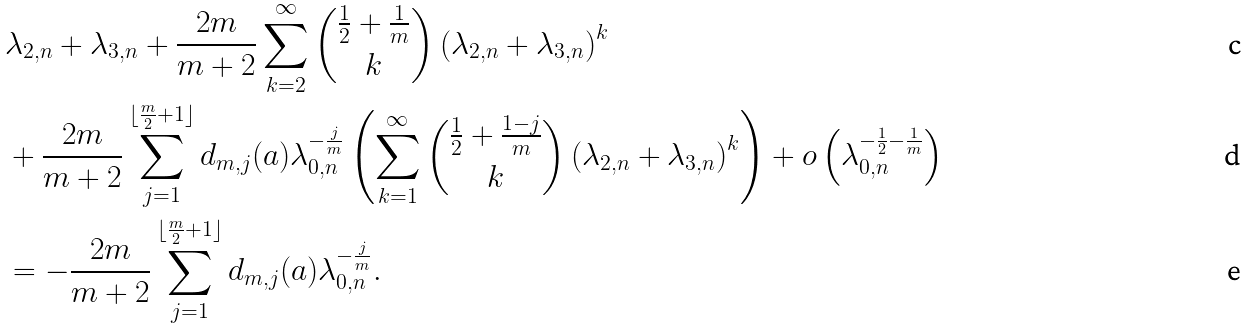Convert formula to latex. <formula><loc_0><loc_0><loc_500><loc_500>& \lambda _ { 2 , n } + \lambda _ { 3 , n } + \frac { 2 m } { m + 2 } \sum _ { k = 2 } ^ { \infty } { \frac { 1 } { 2 } + \frac { 1 } { m } \choose k } \left ( \lambda _ { 2 , n } + \lambda _ { 3 , n } \right ) ^ { k } \\ & + \frac { 2 m } { m + 2 } \sum _ { j = 1 } ^ { \lfloor \frac { m } { 2 } + 1 \rfloor } d _ { m , j } ( a ) \lambda _ { 0 , n } ^ { - \frac { j } { m } } \left ( \sum _ { k = 1 } ^ { \infty } { \frac { 1 } { 2 } + \frac { 1 - j } { m } \choose k } \left ( \lambda _ { 2 , n } + \lambda _ { 3 , n } \right ) ^ { k } \right ) + o \left ( \lambda _ { 0 , n } ^ { - \frac { 1 } { 2 } - \frac { 1 } { m } } \right ) \\ & = - \frac { 2 m } { m + 2 } \sum _ { j = 1 } ^ { \lfloor \frac { m } { 2 } + 1 \rfloor } d _ { m , j } ( a ) \lambda _ { 0 , n } ^ { - \frac { j } { m } } .</formula> 